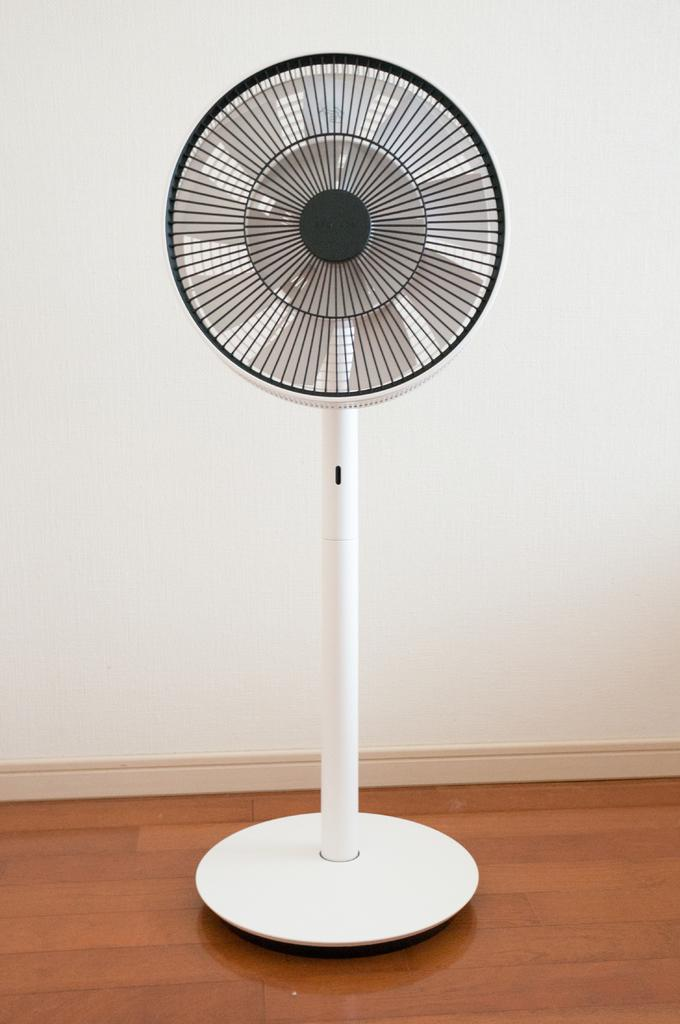What object can be seen in the image that is used for cooling? There is a fan in the image that is used for cooling. Where is the fan located in the image? The fan is on the wooden floor in the image. What can be seen in the background of the image? There is a wall in the background of the image. What type of knowledge can be gained from the drain in the image? There is no drain present in the image, so no knowledge can be gained from it. 